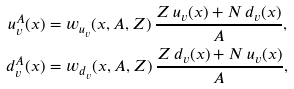Convert formula to latex. <formula><loc_0><loc_0><loc_500><loc_500>u _ { v } ^ { A } ( x ) & = w _ { u _ { v } } ( x , A , Z ) \, \frac { Z \, u _ { v } ( x ) + N \, d _ { v } ( x ) } { A } , \\ d _ { v } ^ { A } ( x ) & = w _ { d _ { v } } ( x , A , Z ) \, \frac { Z \, d _ { v } ( x ) + N \, u _ { v } ( x ) } { A } ,</formula> 